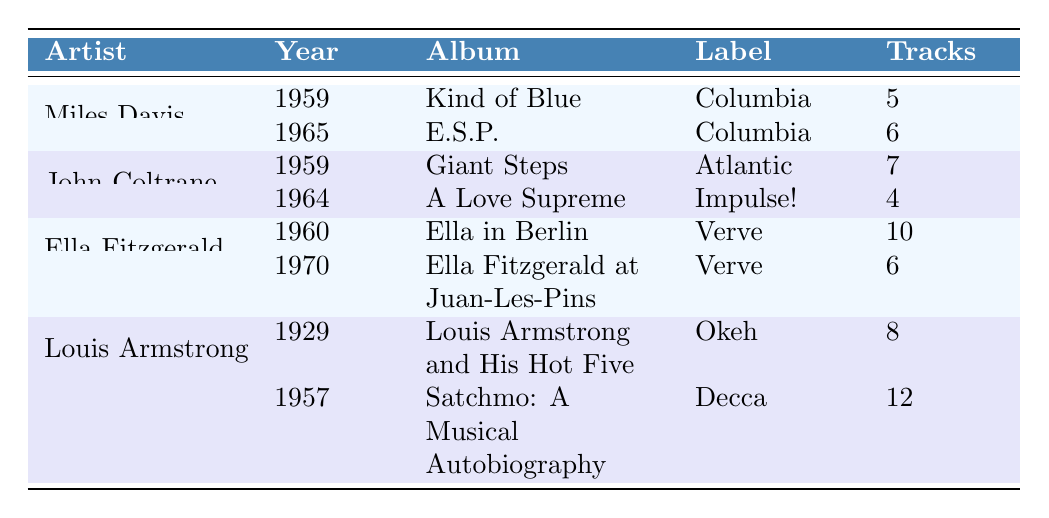What is the title of the album released by Ella Fitzgerald in 1960? Referring to the table, Ella Fitzgerald has an album from 1960 titled "Ella in Berlin."
Answer: Ella in Berlin How many tracks are on Louis Armstrong's album "Satchmo: A Musical Autobiography"? The table lists the album "Satchmo: A Musical Autobiography" under Louis Armstrong and states that it has 12 tracks.
Answer: 12 Which artist has the album "Giant Steps"? The table shows that "Giant Steps" is an album by John Coltrane.
Answer: John Coltrane What is the average number of tracks for Miles Davis's albums? Miles Davis has two albums: "Kind of Blue" with 5 tracks and "E.S.P." with 6 tracks. The average is (5 + 6) / 2 = 5.5.
Answer: 5.5 Is "A Love Supreme" by John Coltrane released in the 1950s? The table indicates that "A Love Supreme" was released in 1964, which is not in the 1950s.
Answer: No How many albums did Louis Armstrong release before 1960? According to the table, Louis Armstrong released two albums: "Louis Armstrong and His Hot Five" in 1929 and "Satchmo: A Musical Autobiography" in 1957. Thus, he released 2 albums before 1960.
Answer: 2 Which artist has the highest total number of tracks listed in their albums? For each artist: Miles Davis has 11 tracks, John Coltrane has 11 tracks, Ella Fitzgerald has 16 tracks, and Louis Armstrong has 20 tracks. Louis Armstrong has the highest total.
Answer: Louis Armstrong In what year was "Kind of Blue" released? The table indicates that "Kind of Blue" was released by Miles Davis in 1959.
Answer: 1959 What is the label for John Coltrane's album "A Love Supreme"? The table shows that "A Love Supreme" by John Coltrane is released under the label "Impulse!"
Answer: Impulse! 